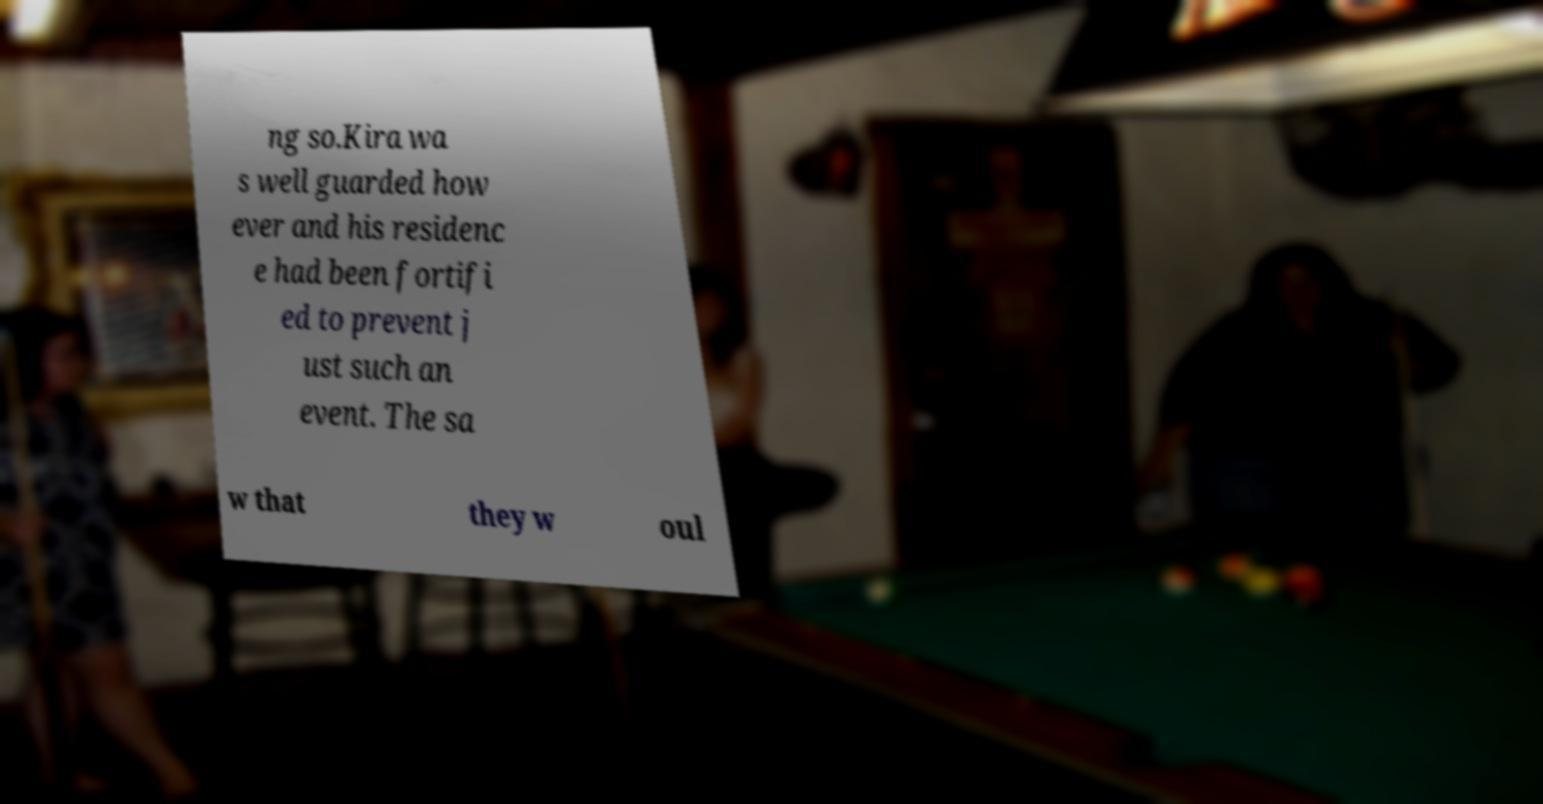Could you extract and type out the text from this image? ng so.Kira wa s well guarded how ever and his residenc e had been fortifi ed to prevent j ust such an event. The sa w that they w oul 